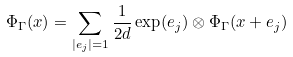<formula> <loc_0><loc_0><loc_500><loc_500>\Phi _ { \Gamma } ( x ) = \sum _ { | e _ { j } | = 1 } \frac { 1 } { 2 d } \exp ( e _ { j } ) \otimes \Phi _ { \Gamma } ( x + e _ { j } )</formula> 